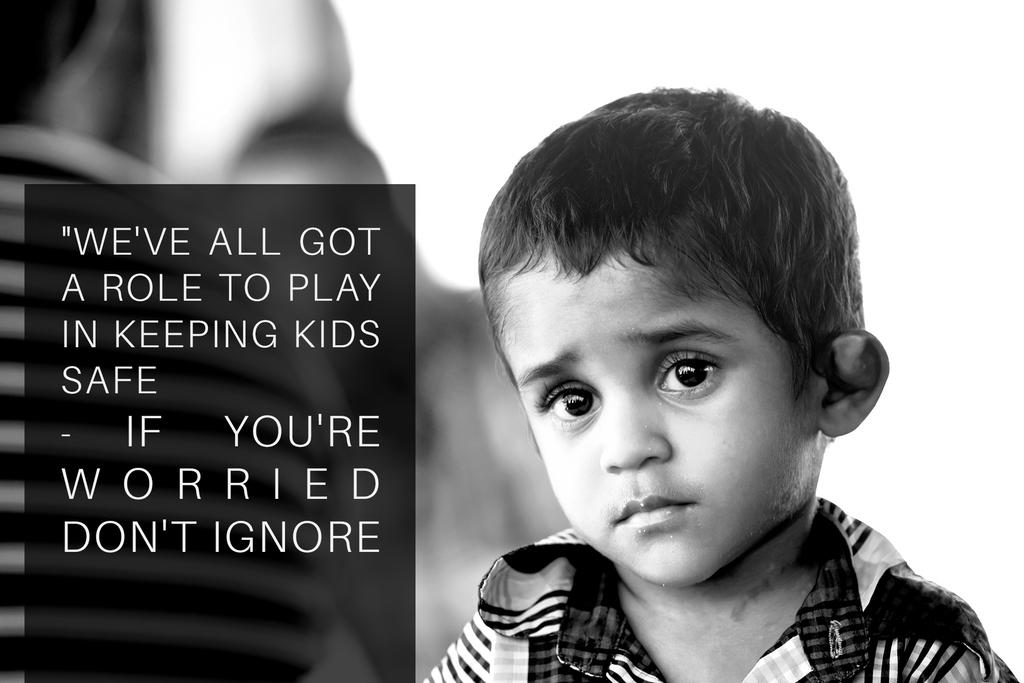What is the main subject of the image? The main subject of the image is a boy. Can you describe any additional elements in the image? Yes, there is some text written in the image. What type of skirt is the father wearing in the image? There is no father or skirt present in the image; it features a boy and some text. 